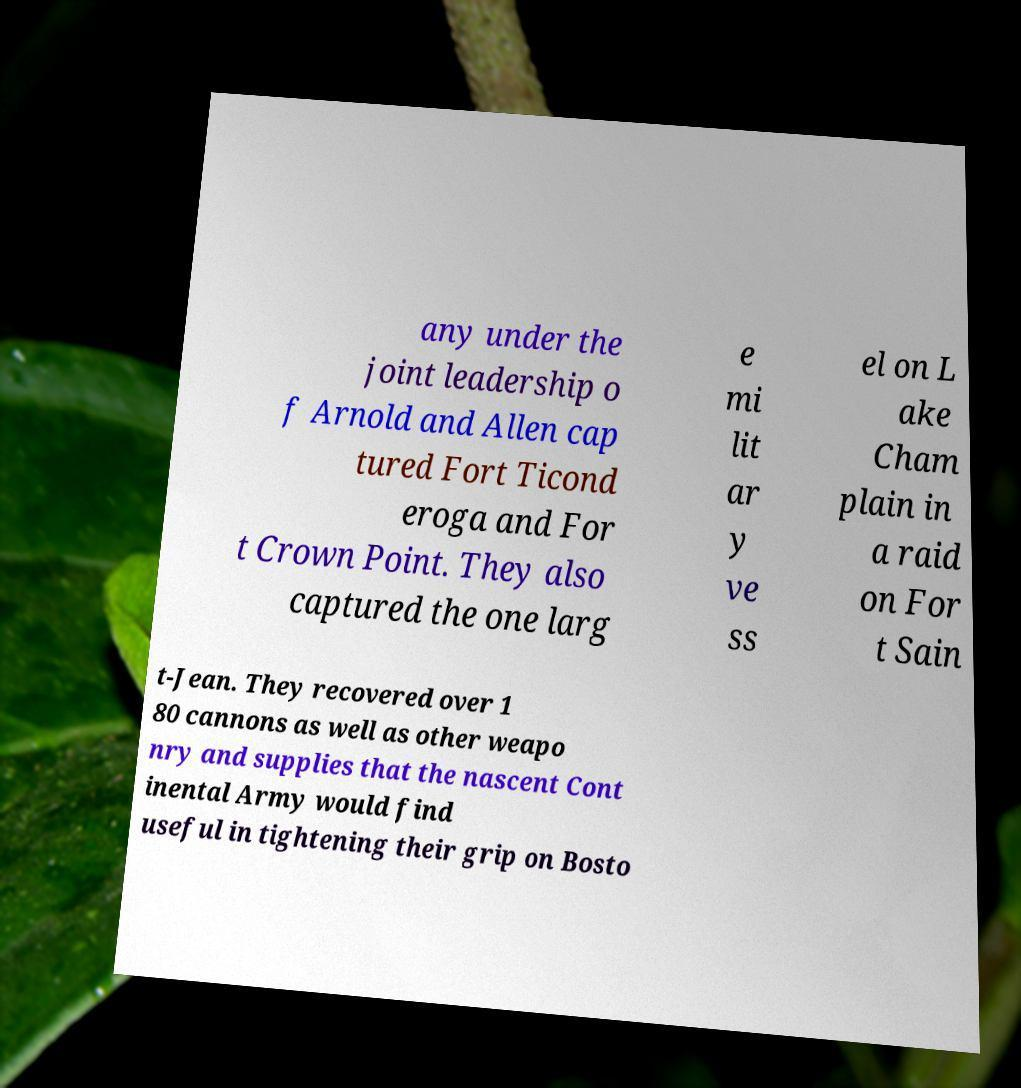Could you assist in decoding the text presented in this image and type it out clearly? any under the joint leadership o f Arnold and Allen cap tured Fort Ticond eroga and For t Crown Point. They also captured the one larg e mi lit ar y ve ss el on L ake Cham plain in a raid on For t Sain t-Jean. They recovered over 1 80 cannons as well as other weapo nry and supplies that the nascent Cont inental Army would find useful in tightening their grip on Bosto 